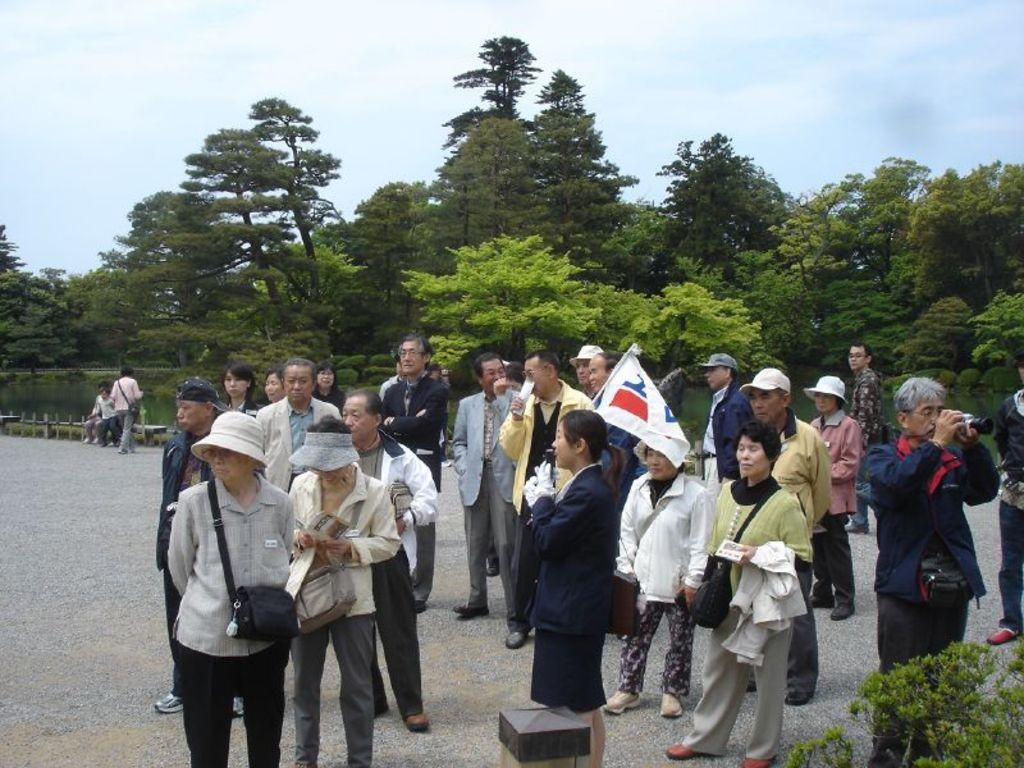How would you summarize this image in a sentence or two? This image consists of a many people standing on the ground. In the middle, there is a woman holding a flag. At the bottom, there is a road. In the background, there are trees. At the top, there is sky. 